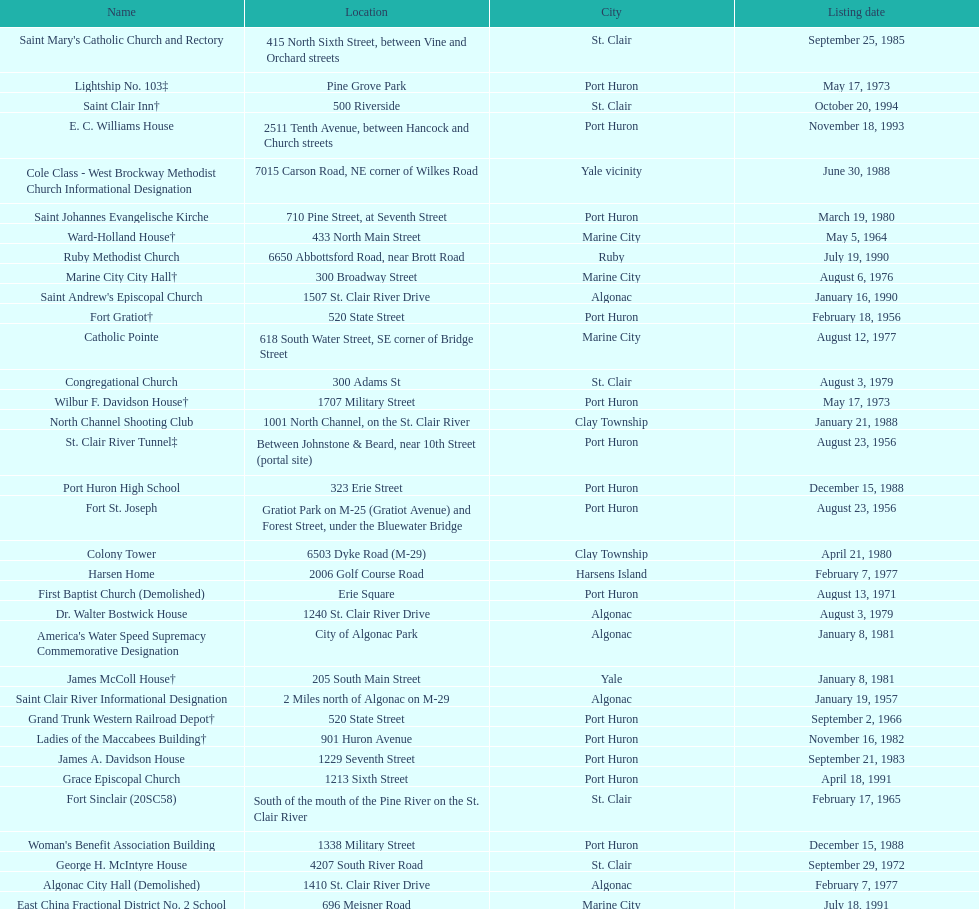Which city is home to the greatest number of historic sites, existing or demolished? Port Huron. 